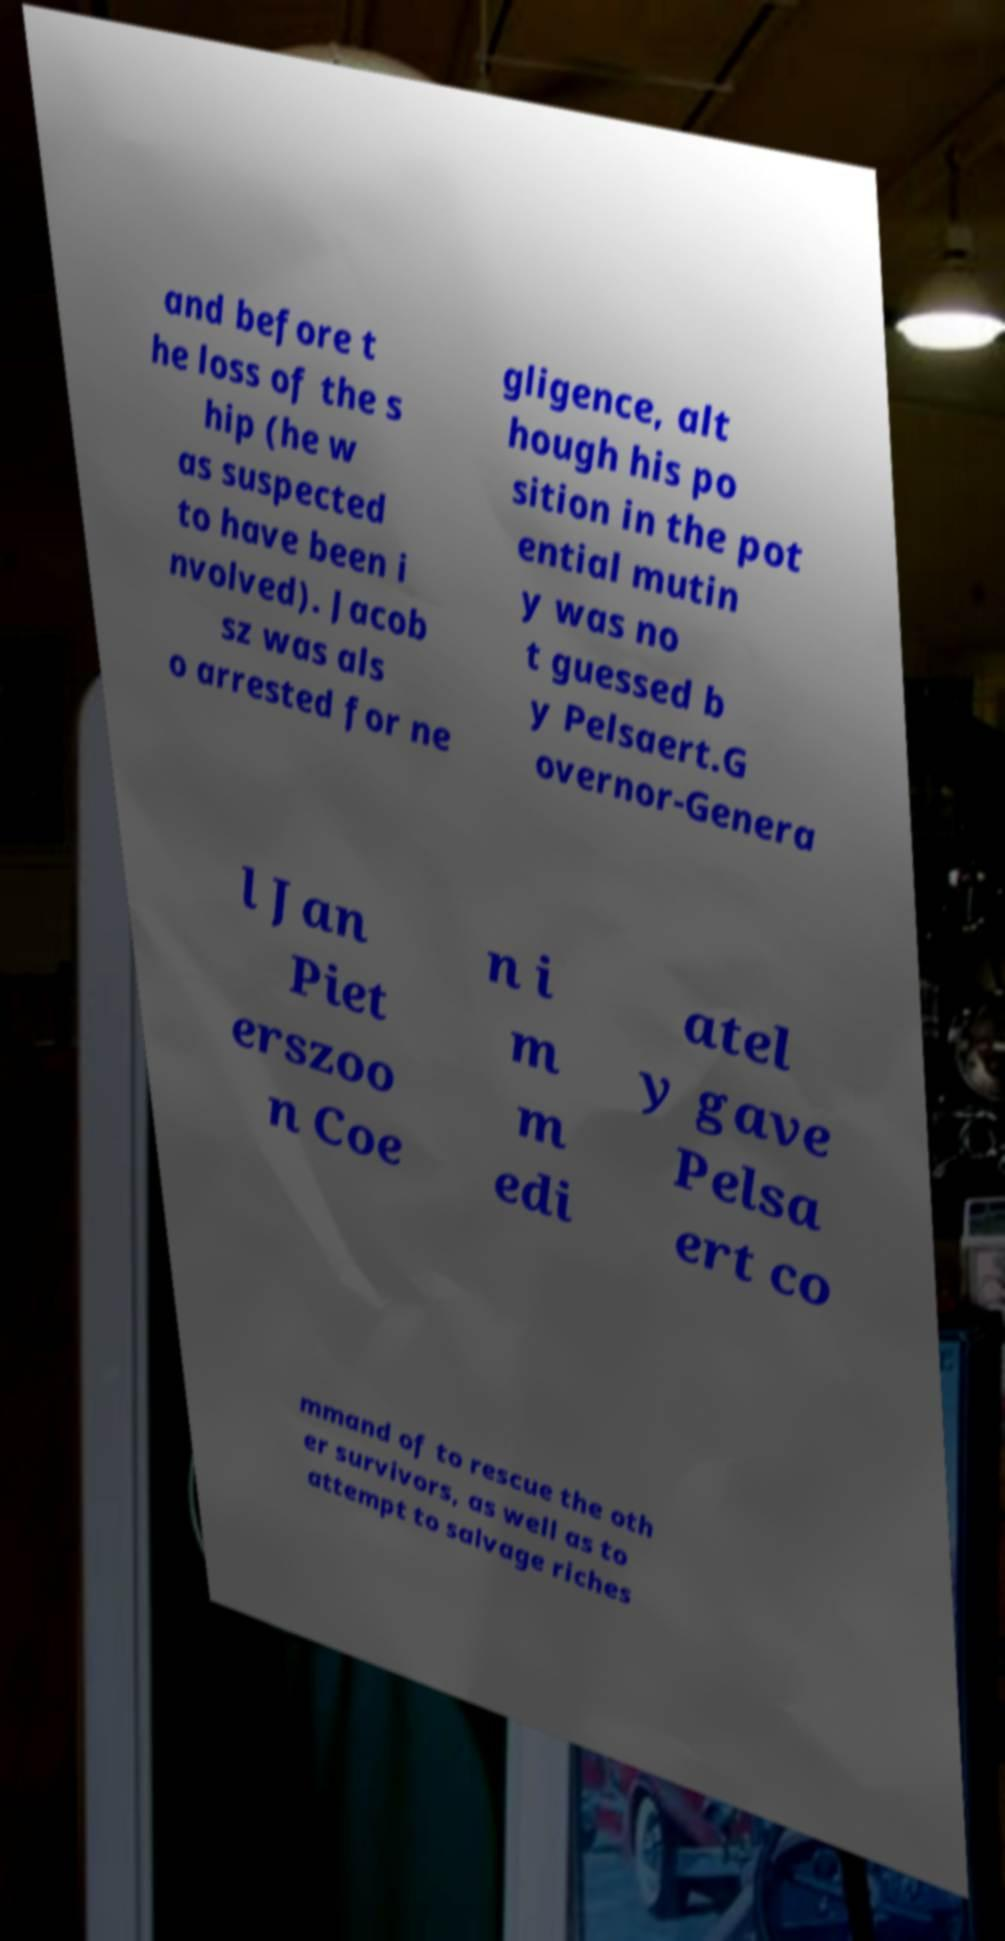There's text embedded in this image that I need extracted. Can you transcribe it verbatim? and before t he loss of the s hip (he w as suspected to have been i nvolved). Jacob sz was als o arrested for ne gligence, alt hough his po sition in the pot ential mutin y was no t guessed b y Pelsaert.G overnor-Genera l Jan Piet erszoo n Coe n i m m edi atel y gave Pelsa ert co mmand of to rescue the oth er survivors, as well as to attempt to salvage riches 